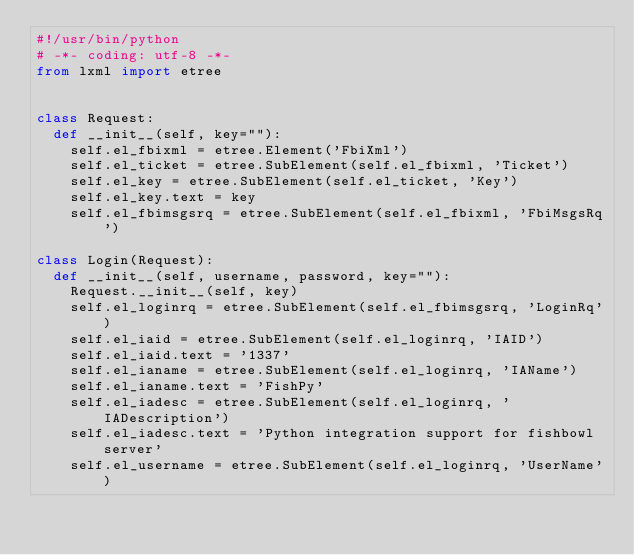Convert code to text. <code><loc_0><loc_0><loc_500><loc_500><_Python_>#!/usr/bin/python
# -*- coding: utf-8 -*-
from lxml import etree


class Request:
	def __init__(self, key=""):
		self.el_fbixml = etree.Element('FbiXml')
		self.el_ticket = etree.SubElement(self.el_fbixml, 'Ticket')
		self.el_key = etree.SubElement(self.el_ticket, 'Key')
		self.el_key.text = key
		self.el_fbimsgsrq = etree.SubElement(self.el_fbixml, 'FbiMsgsRq')

class Login(Request):
	def __init__(self, username, password, key=""):
		Request.__init__(self, key)
		self.el_loginrq = etree.SubElement(self.el_fbimsgsrq, 'LoginRq')
		self.el_iaid = etree.SubElement(self.el_loginrq, 'IAID')
		self.el_iaid.text = '1337'
		self.el_ianame = etree.SubElement(self.el_loginrq, 'IAName')
		self.el_ianame.text = 'FishPy'
		self.el_iadesc = etree.SubElement(self.el_loginrq, 'IADescription')
		self.el_iadesc.text = 'Python integration support for fishbowl server'
		self.el_username = etree.SubElement(self.el_loginrq, 'UserName')</code> 